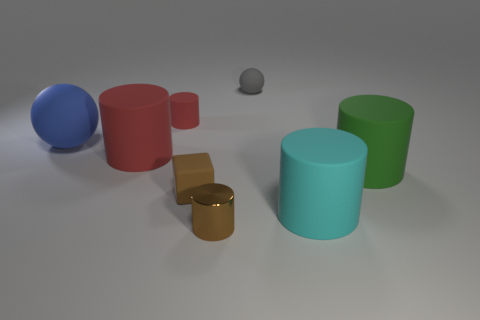Is there any other thing that is made of the same material as the tiny brown cylinder?
Your answer should be compact. No. Are there any other things that have the same shape as the small brown matte thing?
Keep it short and to the point. No. Does the big blue sphere have the same material as the small brown object in front of the large cyan rubber object?
Provide a succinct answer. No. Is the number of red cylinders left of the blue thing less than the number of cyan objects in front of the gray matte ball?
Ensure brevity in your answer.  Yes. The block that is the same material as the gray sphere is what color?
Make the answer very short. Brown. Are there any big objects that are to the left of the matte sphere that is right of the blue thing?
Offer a very short reply. Yes. What color is the cylinder that is the same size as the brown metal object?
Keep it short and to the point. Red. What number of objects are tiny shiny blocks or shiny things?
Provide a succinct answer. 1. How big is the matte ball on the left side of the cylinder to the left of the small rubber thing that is left of the small brown cube?
Offer a terse response. Large. What number of metal things are the same color as the small block?
Offer a terse response. 1. 